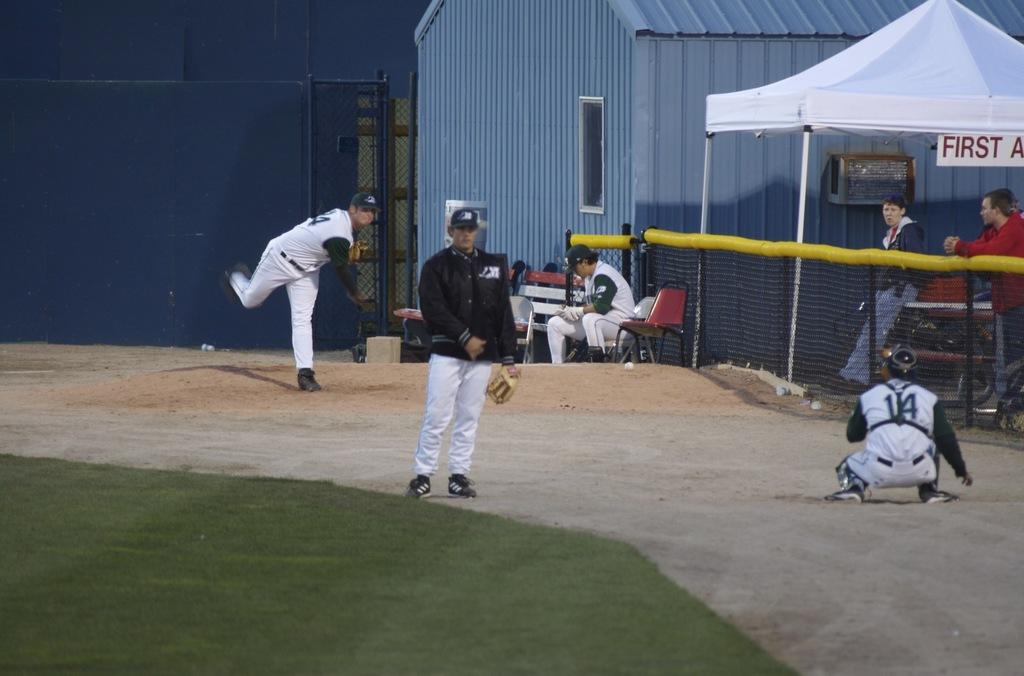<image>
Provide a brief description of the given image. PITCHERS PRACTICING NEXT TO THE FIRST AID TENT 